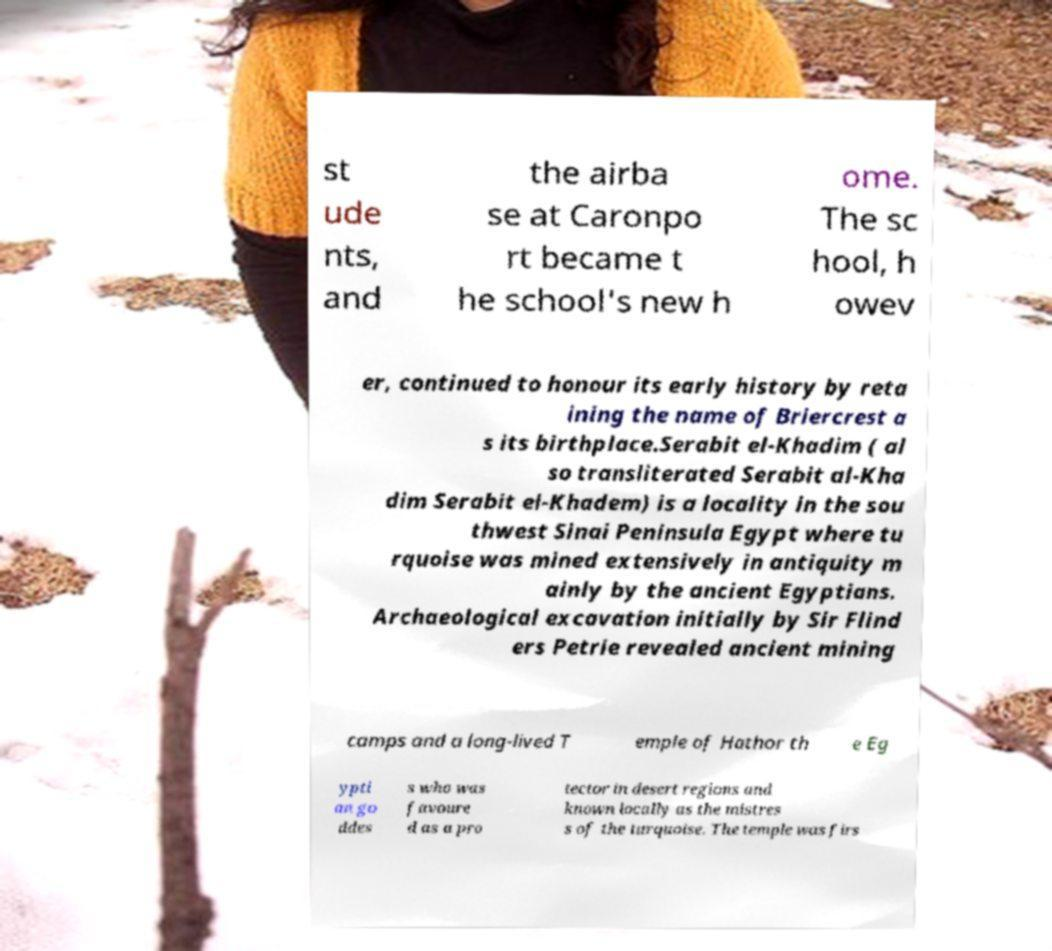What messages or text are displayed in this image? I need them in a readable, typed format. st ude nts, and the airba se at Caronpo rt became t he school's new h ome. The sc hool, h owev er, continued to honour its early history by reta ining the name of Briercrest a s its birthplace.Serabit el-Khadim ( al so transliterated Serabit al-Kha dim Serabit el-Khadem) is a locality in the sou thwest Sinai Peninsula Egypt where tu rquoise was mined extensively in antiquity m ainly by the ancient Egyptians. Archaeological excavation initially by Sir Flind ers Petrie revealed ancient mining camps and a long-lived T emple of Hathor th e Eg ypti an go ddes s who was favoure d as a pro tector in desert regions and known locally as the mistres s of the turquoise. The temple was firs 